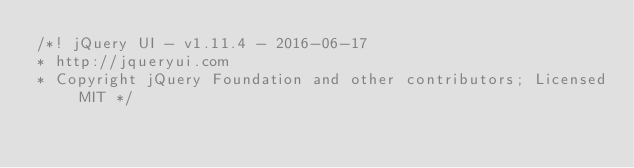<code> <loc_0><loc_0><loc_500><loc_500><_CSS_>/*! jQuery UI - v1.11.4 - 2016-06-17
* http://jqueryui.com
* Copyright jQuery Foundation and other contributors; Licensed MIT */
</code> 